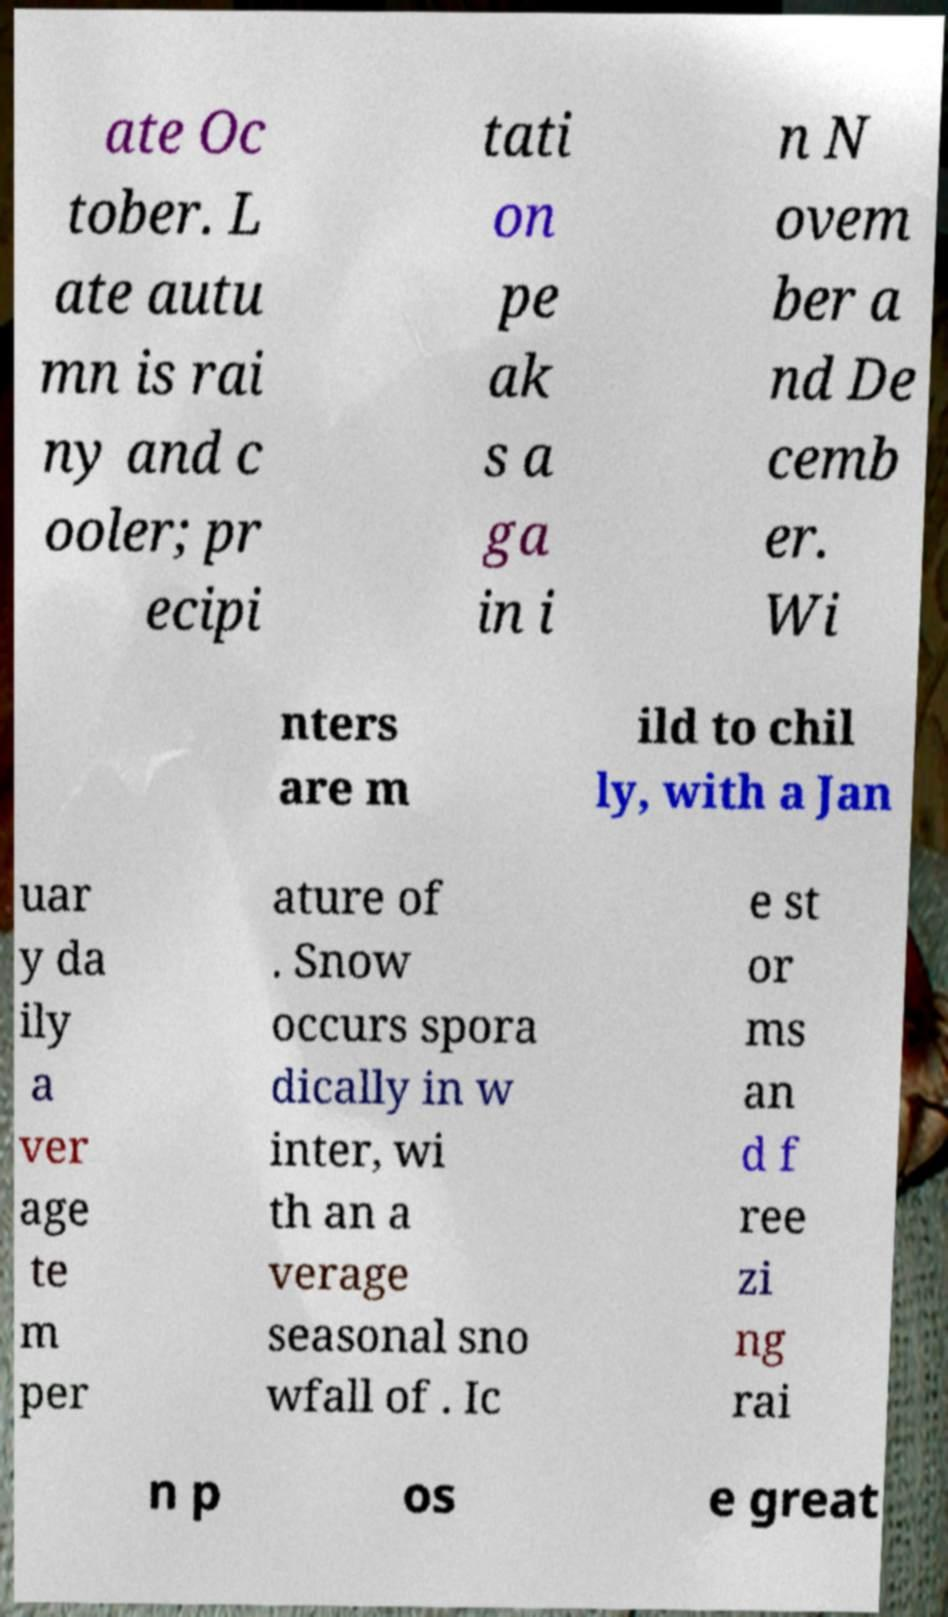Please identify and transcribe the text found in this image. ate Oc tober. L ate autu mn is rai ny and c ooler; pr ecipi tati on pe ak s a ga in i n N ovem ber a nd De cemb er. Wi nters are m ild to chil ly, with a Jan uar y da ily a ver age te m per ature of . Snow occurs spora dically in w inter, wi th an a verage seasonal sno wfall of . Ic e st or ms an d f ree zi ng rai n p os e great 